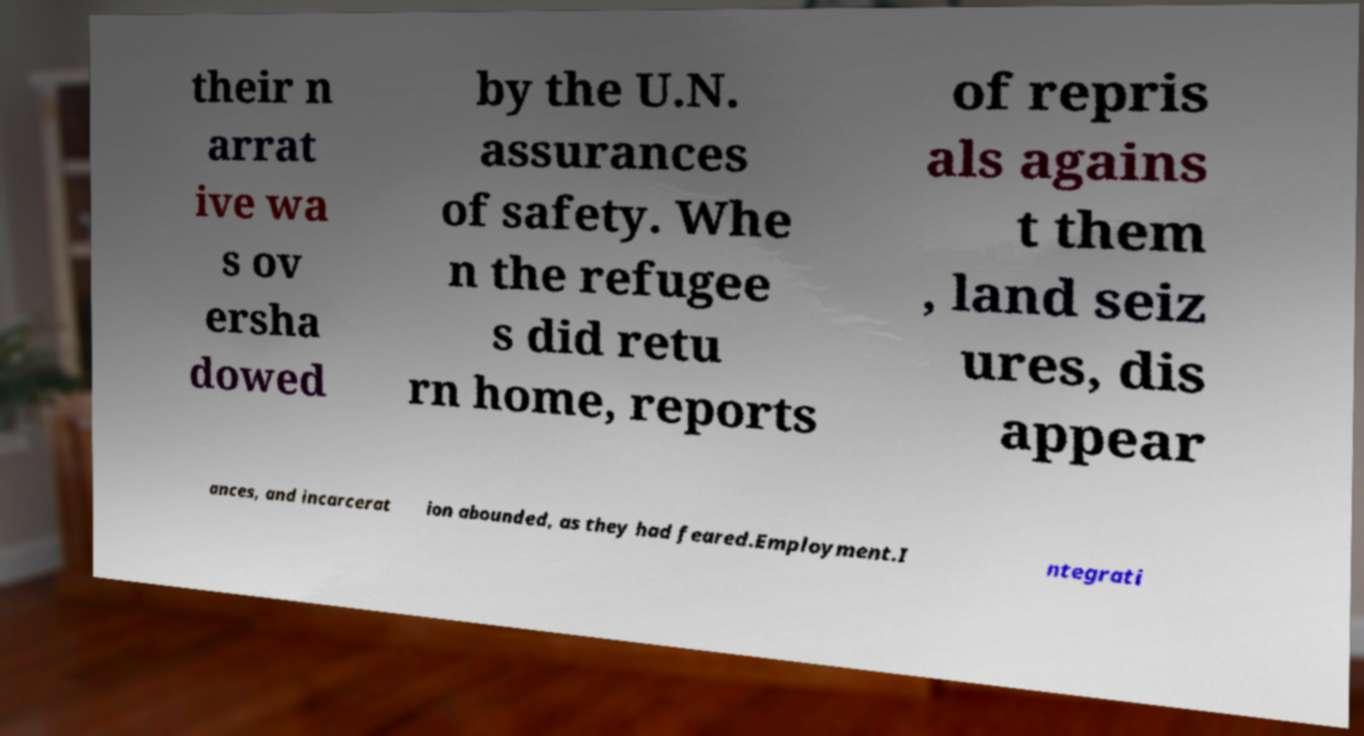Can you accurately transcribe the text from the provided image for me? their n arrat ive wa s ov ersha dowed by the U.N. assurances of safety. Whe n the refugee s did retu rn home, reports of repris als agains t them , land seiz ures, dis appear ances, and incarcerat ion abounded, as they had feared.Employment.I ntegrati 